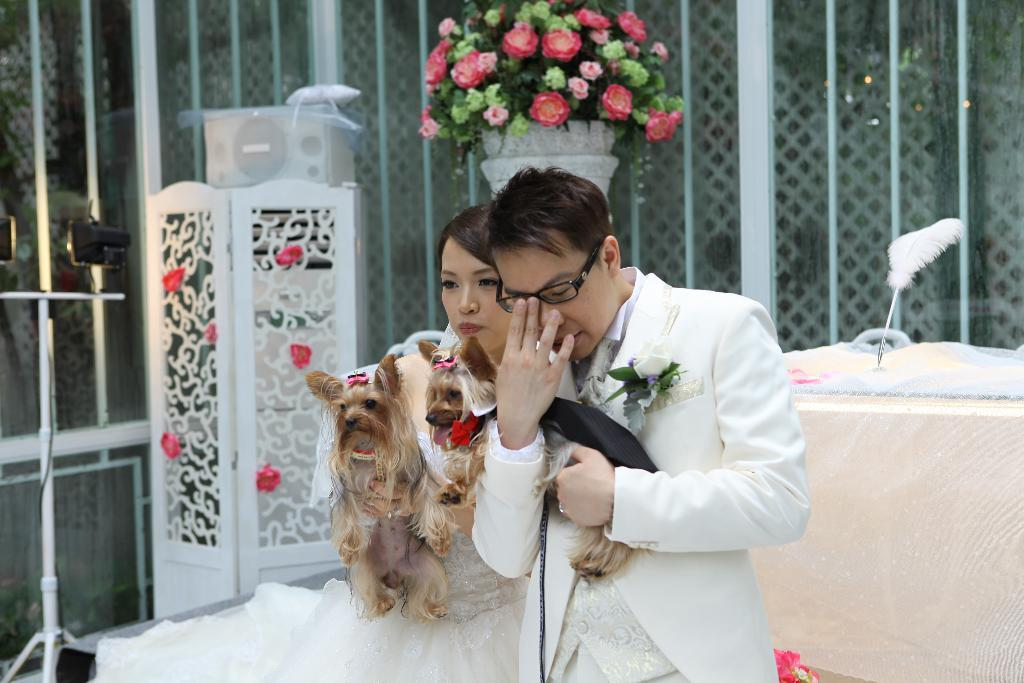How many people are in the image? There are two people in the image, a man and a woman. What is the woman holding in her hands? The woman is holding dogs in her hands. What can be seen in the background of the image? There are flowers and lights in the background of the image. What type of wood is the basketball court made of in the image? There is no basketball court or wood present in the image. What subject is being taught in the school depicted in the image? There is no school depicted in the image. 